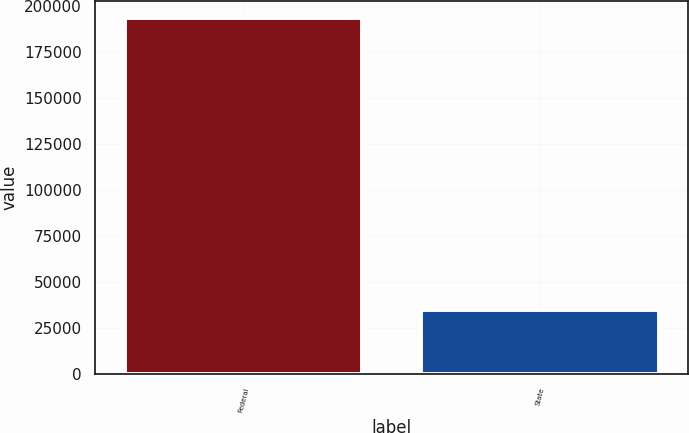<chart> <loc_0><loc_0><loc_500><loc_500><bar_chart><fcel>Federal<fcel>State<nl><fcel>193181<fcel>34415<nl></chart> 